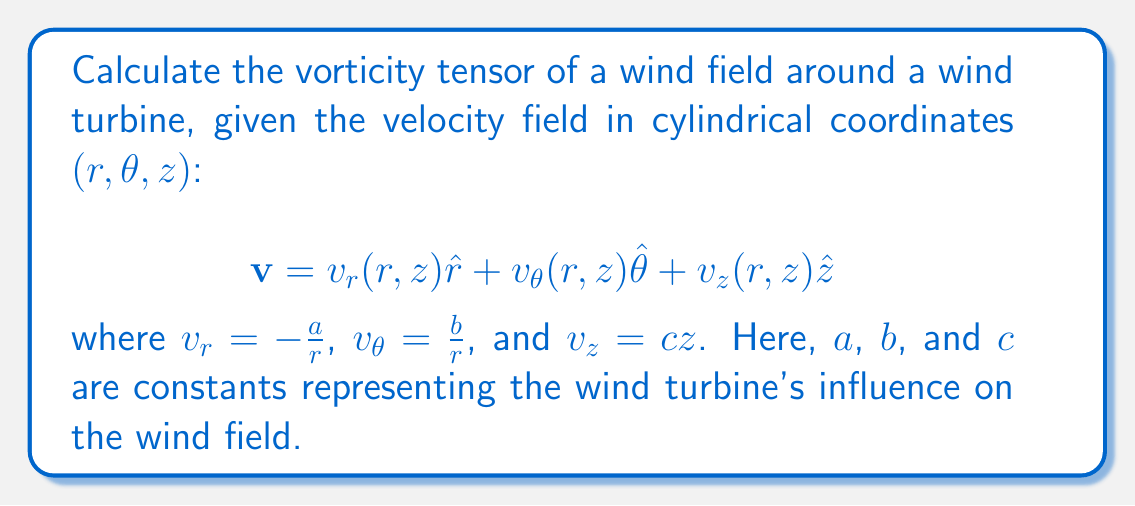Show me your answer to this math problem. To calculate the vorticity tensor, we need to follow these steps:

1) The vorticity tensor $\omega_{ij}$ is defined as:

   $$\omega_{ij} = \frac{1}{2}\left(\frac{\partial v_i}{\partial x_j} - \frac{\partial v_j}{\partial x_i}\right)$$

2) In cylindrical coordinates, we need to use the appropriate expressions for the gradient operator:

   $$\nabla = \hat{r}\frac{\partial}{\partial r} + \hat{\theta}\frac{1}{r}\frac{\partial}{\partial \theta} + \hat{z}\frac{\partial}{\partial z}$$

3) Calculate the partial derivatives:

   $$\frac{\partial v_r}{\partial r} = \frac{a}{r^2}, \frac{\partial v_r}{\partial \theta} = 0, \frac{\partial v_r}{\partial z} = 0$$
   $$\frac{\partial v_\theta}{\partial r} = -\frac{b}{r^2}, \frac{\partial v_\theta}{\partial \theta} = 0, \frac{\partial v_\theta}{\partial z} = 0$$
   $$\frac{\partial v_z}{\partial r} = 0, \frac{\partial v_z}{\partial \theta} = 0, \frac{\partial v_z}{\partial z} = c$$

4) Now, we can calculate each component of the vorticity tensor:

   $$\omega_{rr} = \omega_{\theta\theta} = \omega_{zz} = 0$$

   $$\omega_{r\theta} = \frac{1}{2}\left(\frac{1}{r}\frac{\partial v_r}{\partial \theta} - \frac{\partial v_\theta}{\partial r}\right) = \frac{1}{2}\left(0 + \frac{b}{r^2}\right) = \frac{b}{2r^2}$$

   $$\omega_{\theta r} = -\omega_{r\theta} = -\frac{b}{2r^2}$$

   $$\omega_{rz} = \frac{1}{2}\left(\frac{\partial v_r}{\partial z} - \frac{\partial v_z}{\partial r}\right) = 0$$

   $$\omega_{zr} = -\omega_{rz} = 0$$

   $$\omega_{\theta z} = \frac{1}{2}\left(\frac{1}{r}\frac{\partial v_\theta}{\partial z} - \frac{\partial v_z}{\partial \theta}\right) = 0$$

   $$\omega_{z\theta} = -\omega_{\theta z} = 0$$

5) The vorticity tensor can be written as a 3x3 matrix:

   $$\omega_{ij} = \begin{pmatrix}
   0 & \frac{b}{2r^2} & 0 \\
   -\frac{b}{2r^2} & 0 & 0 \\
   0 & 0 & 0
   \end{pmatrix}$$
Answer: $$\omega_{ij} = \begin{pmatrix}
0 & \frac{b}{2r^2} & 0 \\
-\frac{b}{2r^2} & 0 & 0 \\
0 & 0 & 0
\end{pmatrix}$$ 